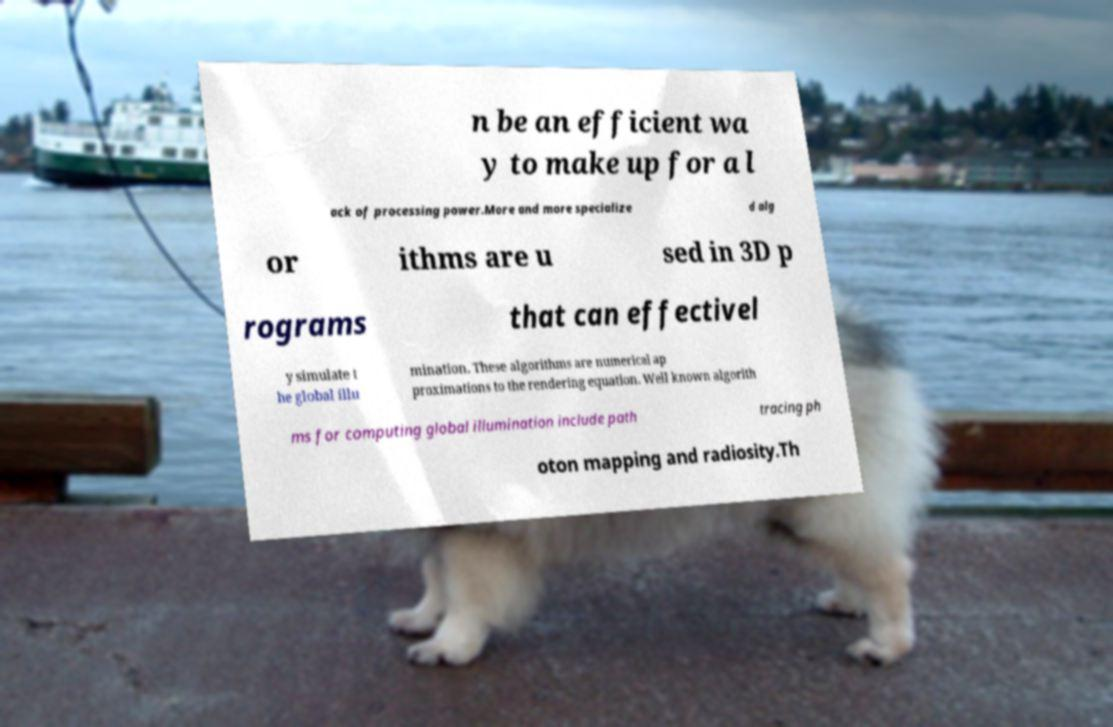Could you assist in decoding the text presented in this image and type it out clearly? n be an efficient wa y to make up for a l ack of processing power.More and more specialize d alg or ithms are u sed in 3D p rograms that can effectivel y simulate t he global illu mination. These algorithms are numerical ap proximations to the rendering equation. Well known algorith ms for computing global illumination include path tracing ph oton mapping and radiosity.Th 